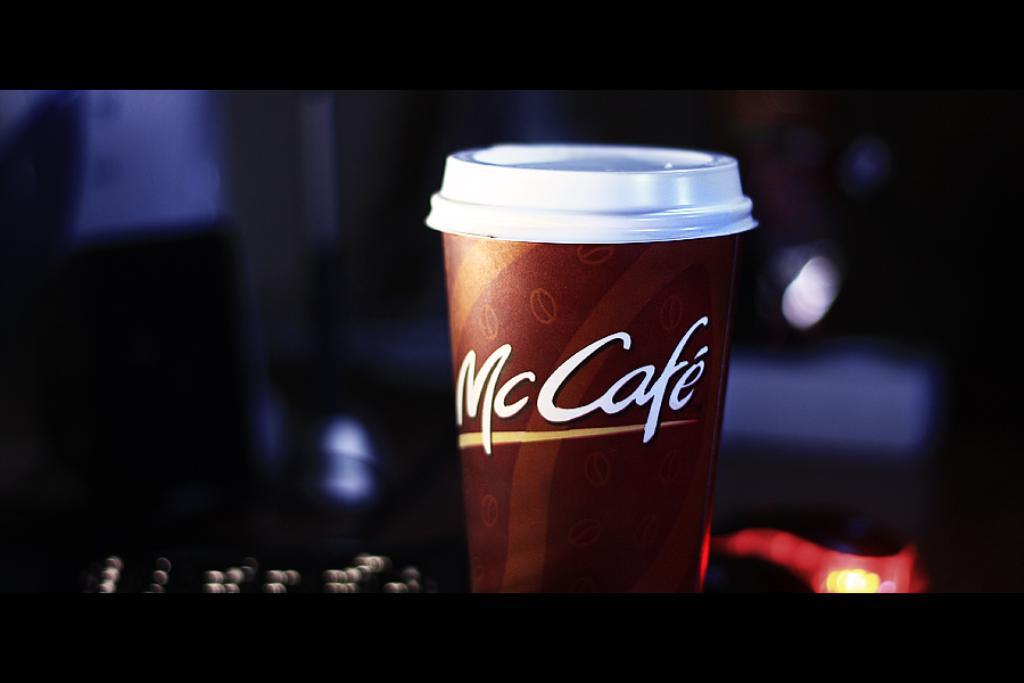What kind of coffee is it?
Offer a terse response. Mccafe. 